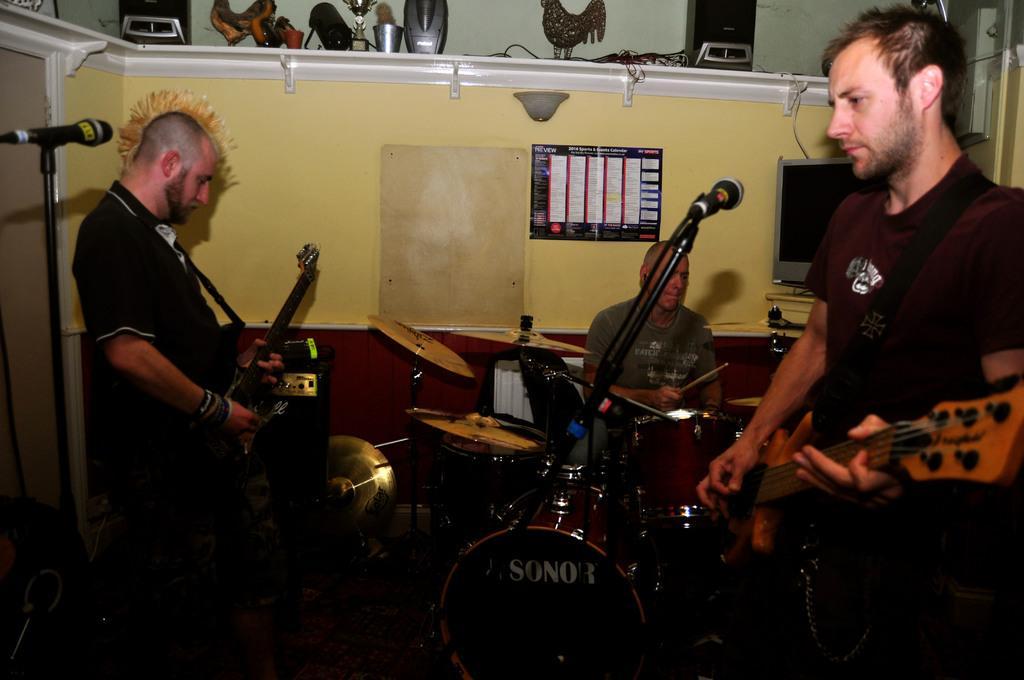How would you summarize this image in a sentence or two? In this picture there is a man playing guitar. There is also other man who is holding a guitar. There is a person who is holding a stick and sitting on the chair. There is a mic, drum and other musical instruments. There is a cup, showpiece and other objects on the shelf. There is a television. 